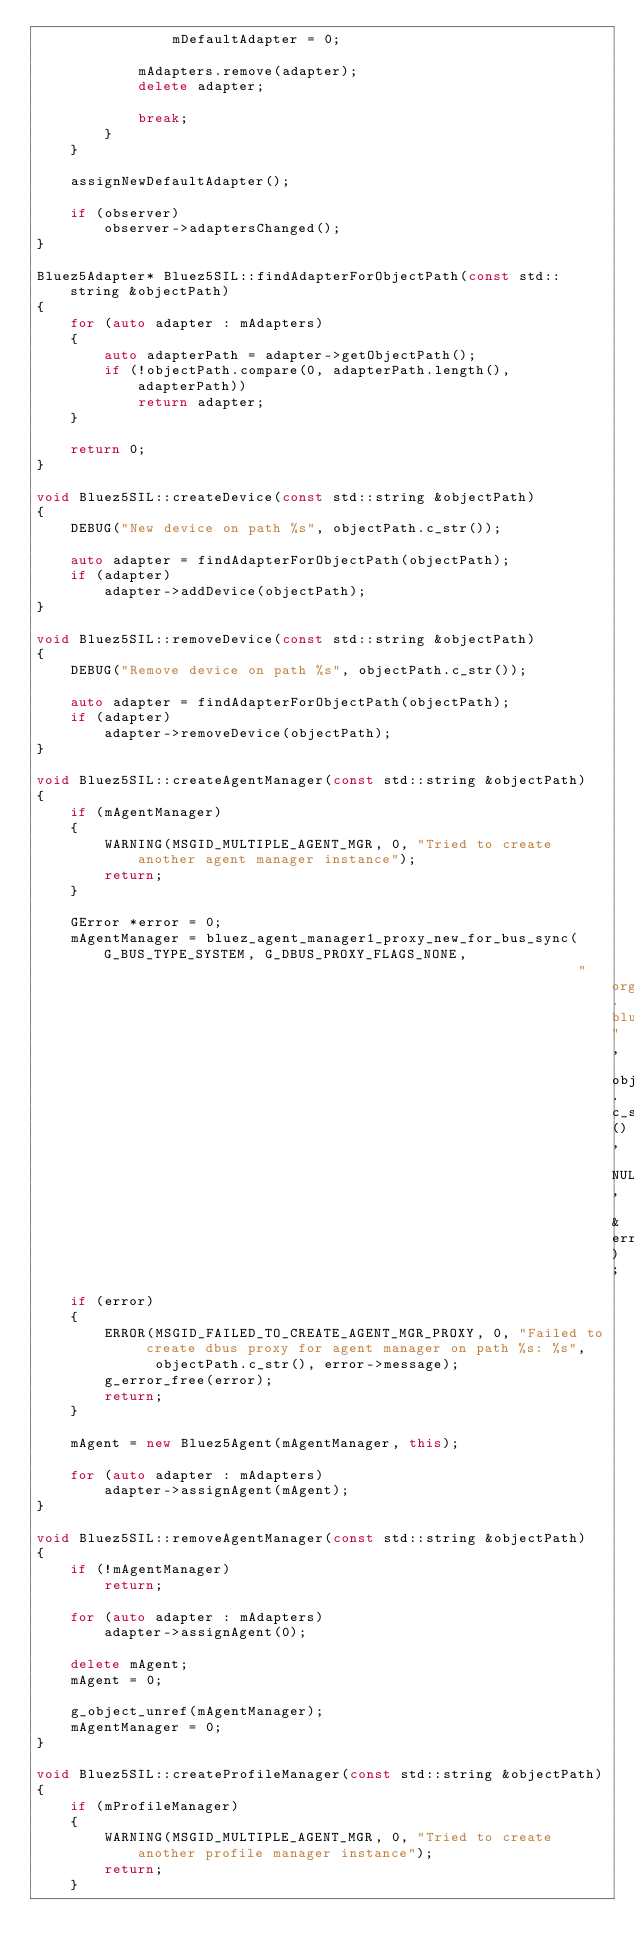Convert code to text. <code><loc_0><loc_0><loc_500><loc_500><_C++_>				mDefaultAdapter = 0;

			mAdapters.remove(adapter);
			delete adapter;

			break;
		}
	}

	assignNewDefaultAdapter();

	if (observer)
		observer->adaptersChanged();
}

Bluez5Adapter* Bluez5SIL::findAdapterForObjectPath(const std::string &objectPath)
{
	for (auto adapter : mAdapters)
	{
		auto adapterPath = adapter->getObjectPath();
		if (!objectPath.compare(0, adapterPath.length(), adapterPath))
			return adapter;
	}

	return 0;
}

void Bluez5SIL::createDevice(const std::string &objectPath)
{
	DEBUG("New device on path %s", objectPath.c_str());

	auto adapter = findAdapterForObjectPath(objectPath);
	if (adapter)
		adapter->addDevice(objectPath);
}

void Bluez5SIL::removeDevice(const std::string &objectPath)
{
	DEBUG("Remove device on path %s", objectPath.c_str());

	auto adapter = findAdapterForObjectPath(objectPath);
	if (adapter)
		adapter->removeDevice(objectPath);
}

void Bluez5SIL::createAgentManager(const std::string &objectPath)
{
	if (mAgentManager)
	{
		WARNING(MSGID_MULTIPLE_AGENT_MGR, 0, "Tried to create another agent manager instance");
		return;
	}

	GError *error = 0;
	mAgentManager = bluez_agent_manager1_proxy_new_for_bus_sync(G_BUS_TYPE_SYSTEM, G_DBUS_PROXY_FLAGS_NONE,
                                                                "org.bluez", objectPath.c_str(), NULL, &error);
	if (error)
	{
		ERROR(MSGID_FAILED_TO_CREATE_AGENT_MGR_PROXY, 0, "Failed to create dbus proxy for agent manager on path %s: %s",
			  objectPath.c_str(), error->message);
		g_error_free(error);
		return;
	}

	mAgent = new Bluez5Agent(mAgentManager, this);

	for (auto adapter : mAdapters)
		adapter->assignAgent(mAgent);
}

void Bluez5SIL::removeAgentManager(const std::string &objectPath)
{
	if (!mAgentManager)
		return;

	for (auto adapter : mAdapters)
		adapter->assignAgent(0);

	delete mAgent;
	mAgent = 0;

	g_object_unref(mAgentManager);
	mAgentManager = 0;
}

void Bluez5SIL::createProfileManager(const std::string &objectPath)
{
	if (mProfileManager)
	{
		WARNING(MSGID_MULTIPLE_AGENT_MGR, 0, "Tried to create another profile manager instance");
		return;
	}
</code> 